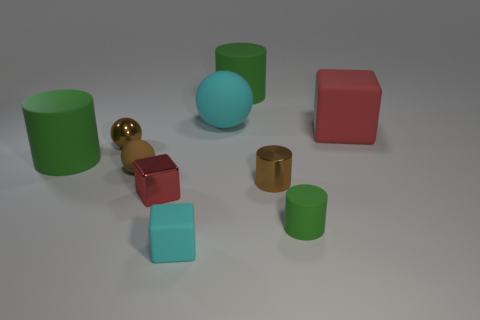What is the shape of the brown shiny object left of the cyan matte object that is behind the small brown thing that is on the right side of the tiny red metallic block?
Your answer should be compact. Sphere. What shape is the big thing that is the same color as the tiny rubber block?
Offer a very short reply. Sphere. There is a block that is both behind the cyan block and to the right of the small red shiny object; what material is it made of?
Keep it short and to the point. Rubber. Is the number of tiny things less than the number of cyan matte cylinders?
Your answer should be compact. No. There is a big red rubber object; is its shape the same as the cyan thing that is in front of the red matte object?
Your response must be concise. Yes. Does the cyan cube to the left of the cyan sphere have the same size as the small red shiny object?
Provide a succinct answer. Yes. What is the shape of the cyan rubber thing that is the same size as the brown matte thing?
Ensure brevity in your answer.  Cube. Does the small cyan matte thing have the same shape as the large cyan object?
Your answer should be compact. No. What number of other tiny shiny things are the same shape as the small green object?
Provide a short and direct response. 1. What number of large green rubber objects are on the left side of the small red cube?
Offer a very short reply. 1. 